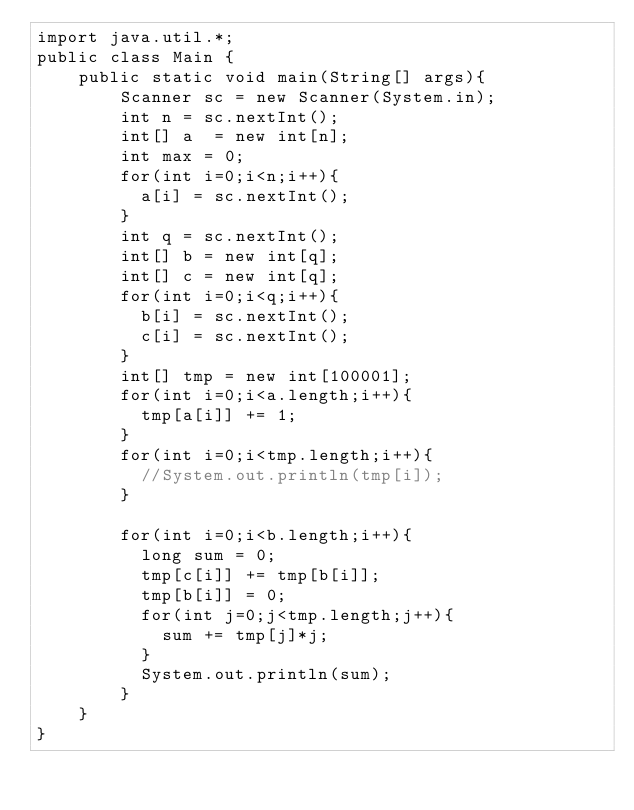<code> <loc_0><loc_0><loc_500><loc_500><_Java_>import java.util.*;
public class Main {
	public static void main(String[] args){
		Scanner sc = new Scanner(System.in);
      	int n = sc.nextInt();
      	int[] a  = new int[n];
      	int max = 0;
      	for(int i=0;i<n;i++){
          a[i] = sc.nextInt();
        }
      	int q = sc.nextInt();
      	int[] b = new int[q];
      	int[] c = new int[q];
      	for(int i=0;i<q;i++){
          b[i] = sc.nextInt();
          c[i] = sc.nextInt();
        }
      	int[] tmp = new int[100001];
      	for(int i=0;i<a.length;i++){
          tmp[a[i]] += 1;
        }
      	for(int i=0;i<tmp.length;i++){
          //System.out.println(tmp[i]);
        }
      	
      	for(int i=0;i<b.length;i++){
          long sum = 0;
          tmp[c[i]] += tmp[b[i]];
          tmp[b[i]] = 0;
          for(int j=0;j<tmp.length;j++){
            sum += tmp[j]*j;
          }
          System.out.println(sum);
        }
	}
}</code> 